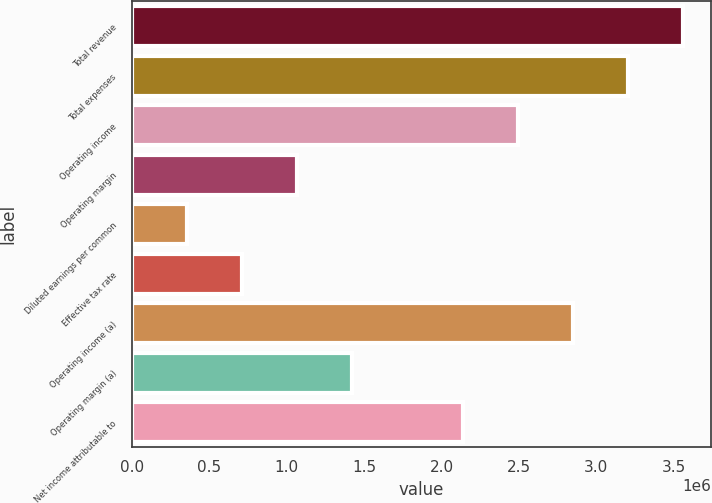Convert chart to OTSL. <chart><loc_0><loc_0><loc_500><loc_500><bar_chart><fcel>Total revenue<fcel>Total expenses<fcel>Operating income<fcel>Operating margin<fcel>Diluted earnings per common<fcel>Effective tax rate<fcel>Operating income (a)<fcel>Operating margin (a)<fcel>Net income attributable to<nl><fcel>3.56097e+06<fcel>3.20487e+06<fcel>2.49268e+06<fcel>1.0683e+06<fcel>356106<fcel>712202<fcel>2.84878e+06<fcel>1.42439e+06<fcel>2.13659e+06<nl></chart> 